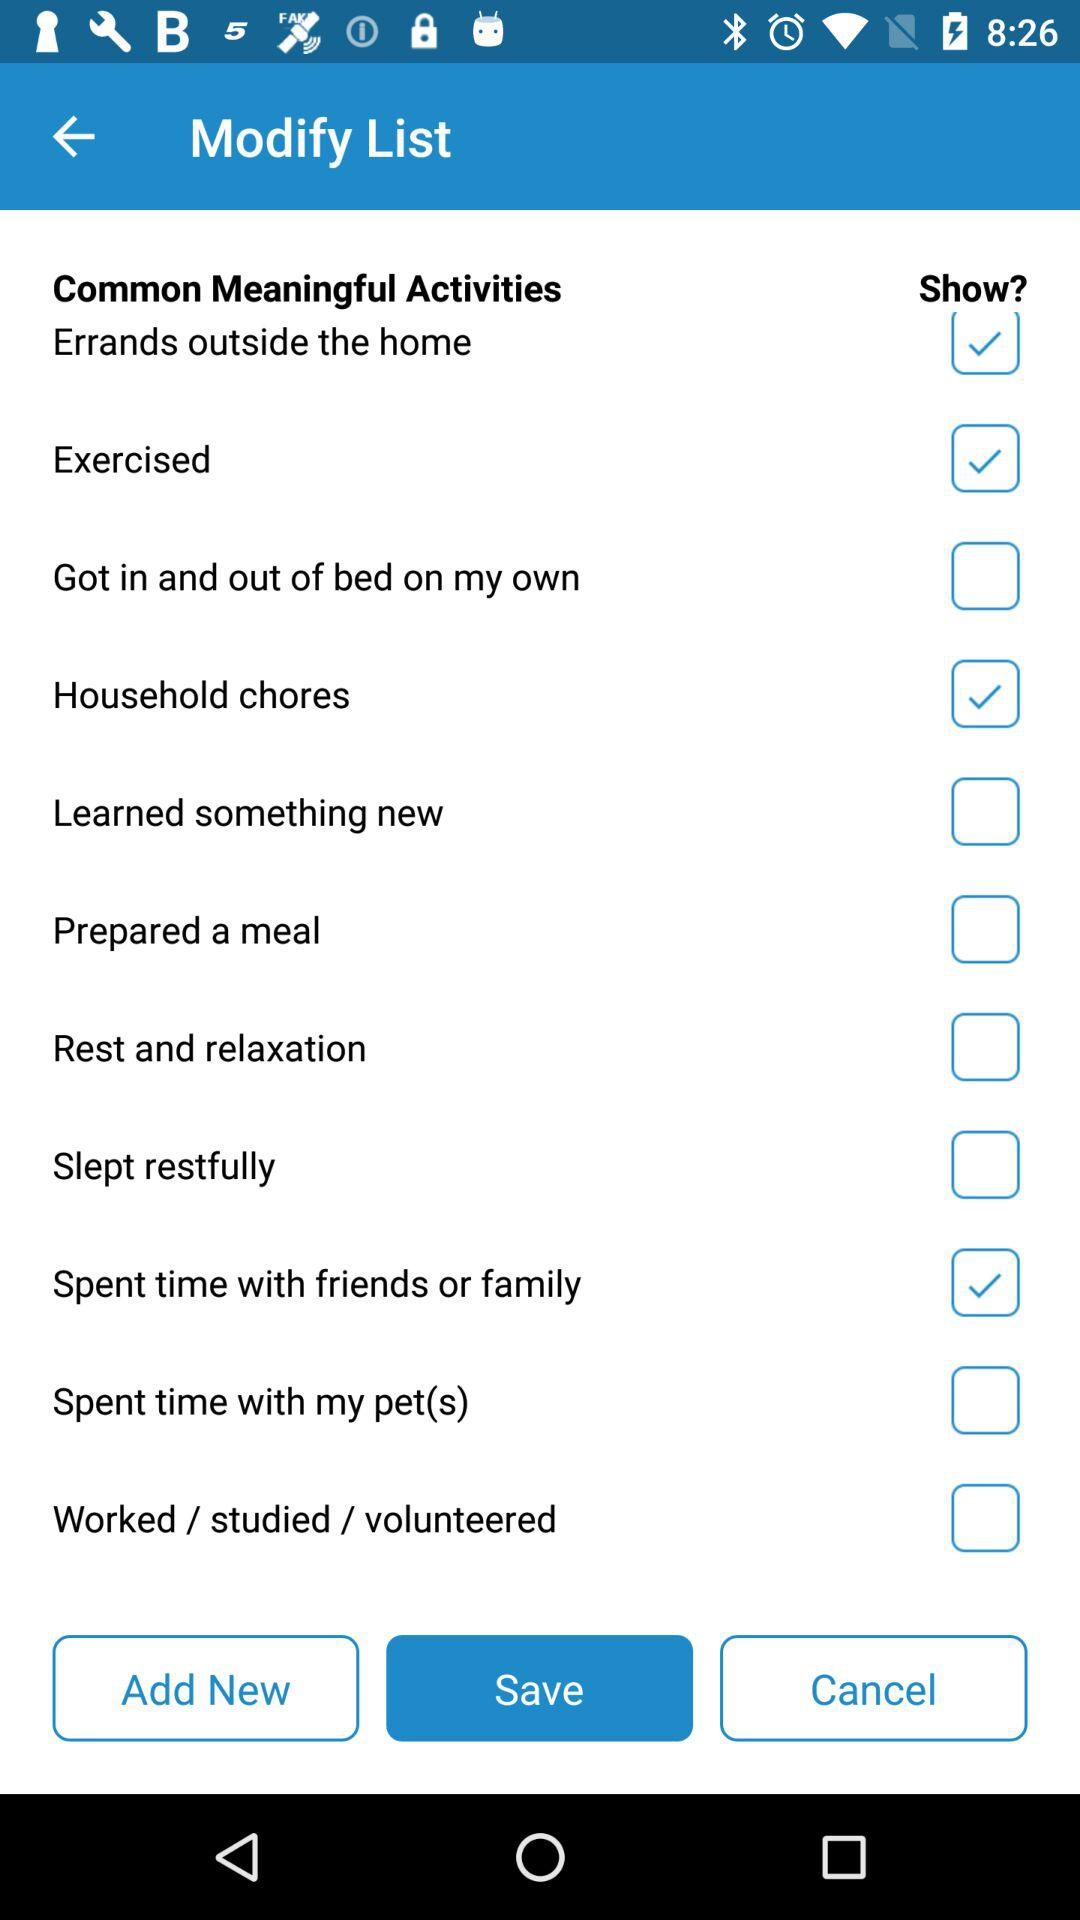Which tab is selected? The selected tab is "Save". 